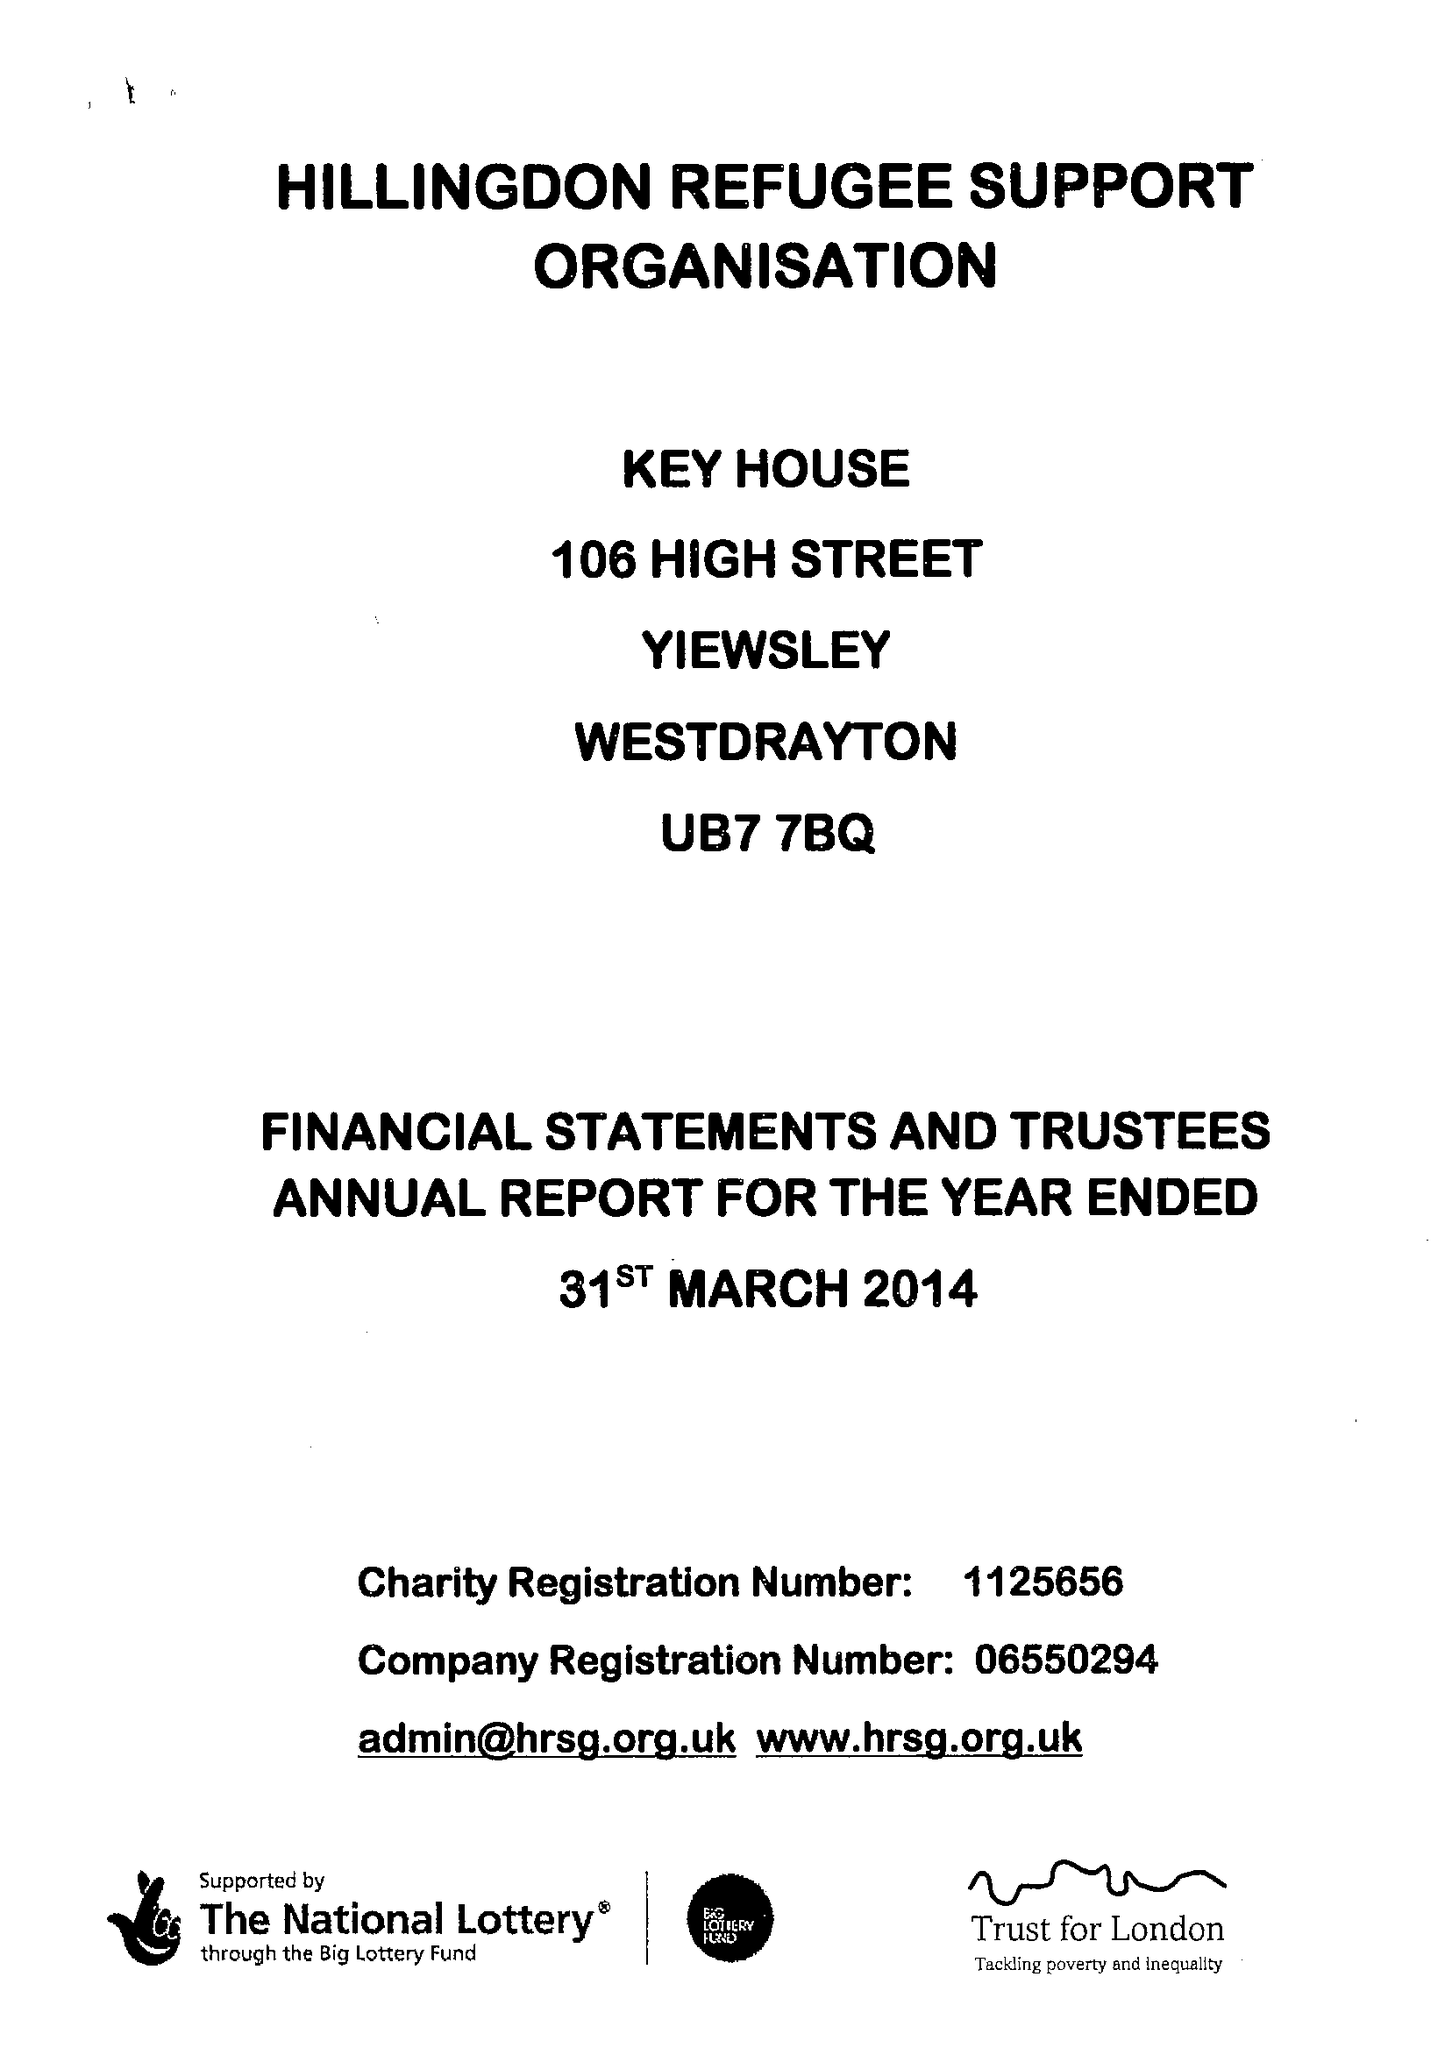What is the value for the report_date?
Answer the question using a single word or phrase. 2014-03-31 